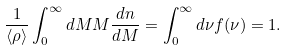<formula> <loc_0><loc_0><loc_500><loc_500>\frac { 1 } { \langle \rho \rangle } \int _ { 0 } ^ { \infty } d M M \frac { d n } { d M } = \int _ { 0 } ^ { \infty } d \nu f ( \nu ) = 1 .</formula> 